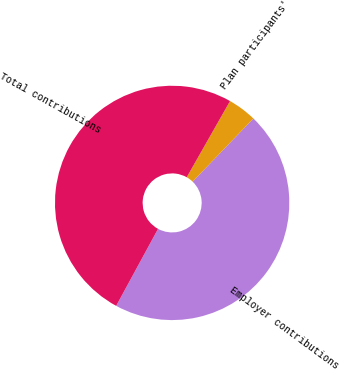Convert chart to OTSL. <chart><loc_0><loc_0><loc_500><loc_500><pie_chart><fcel>Employer contributions<fcel>Plan participants'<fcel>Total contributions<nl><fcel>45.73%<fcel>3.97%<fcel>50.3%<nl></chart> 